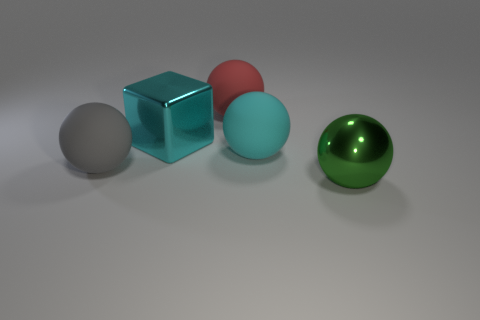What textures can be observed on the objects in the image? The objects exhibit smooth and reflective textures, indicative of polished surfaces. The highlights and reflections on the spheres and cube suggest a glossy finish, common in materials like plastic or glass. 